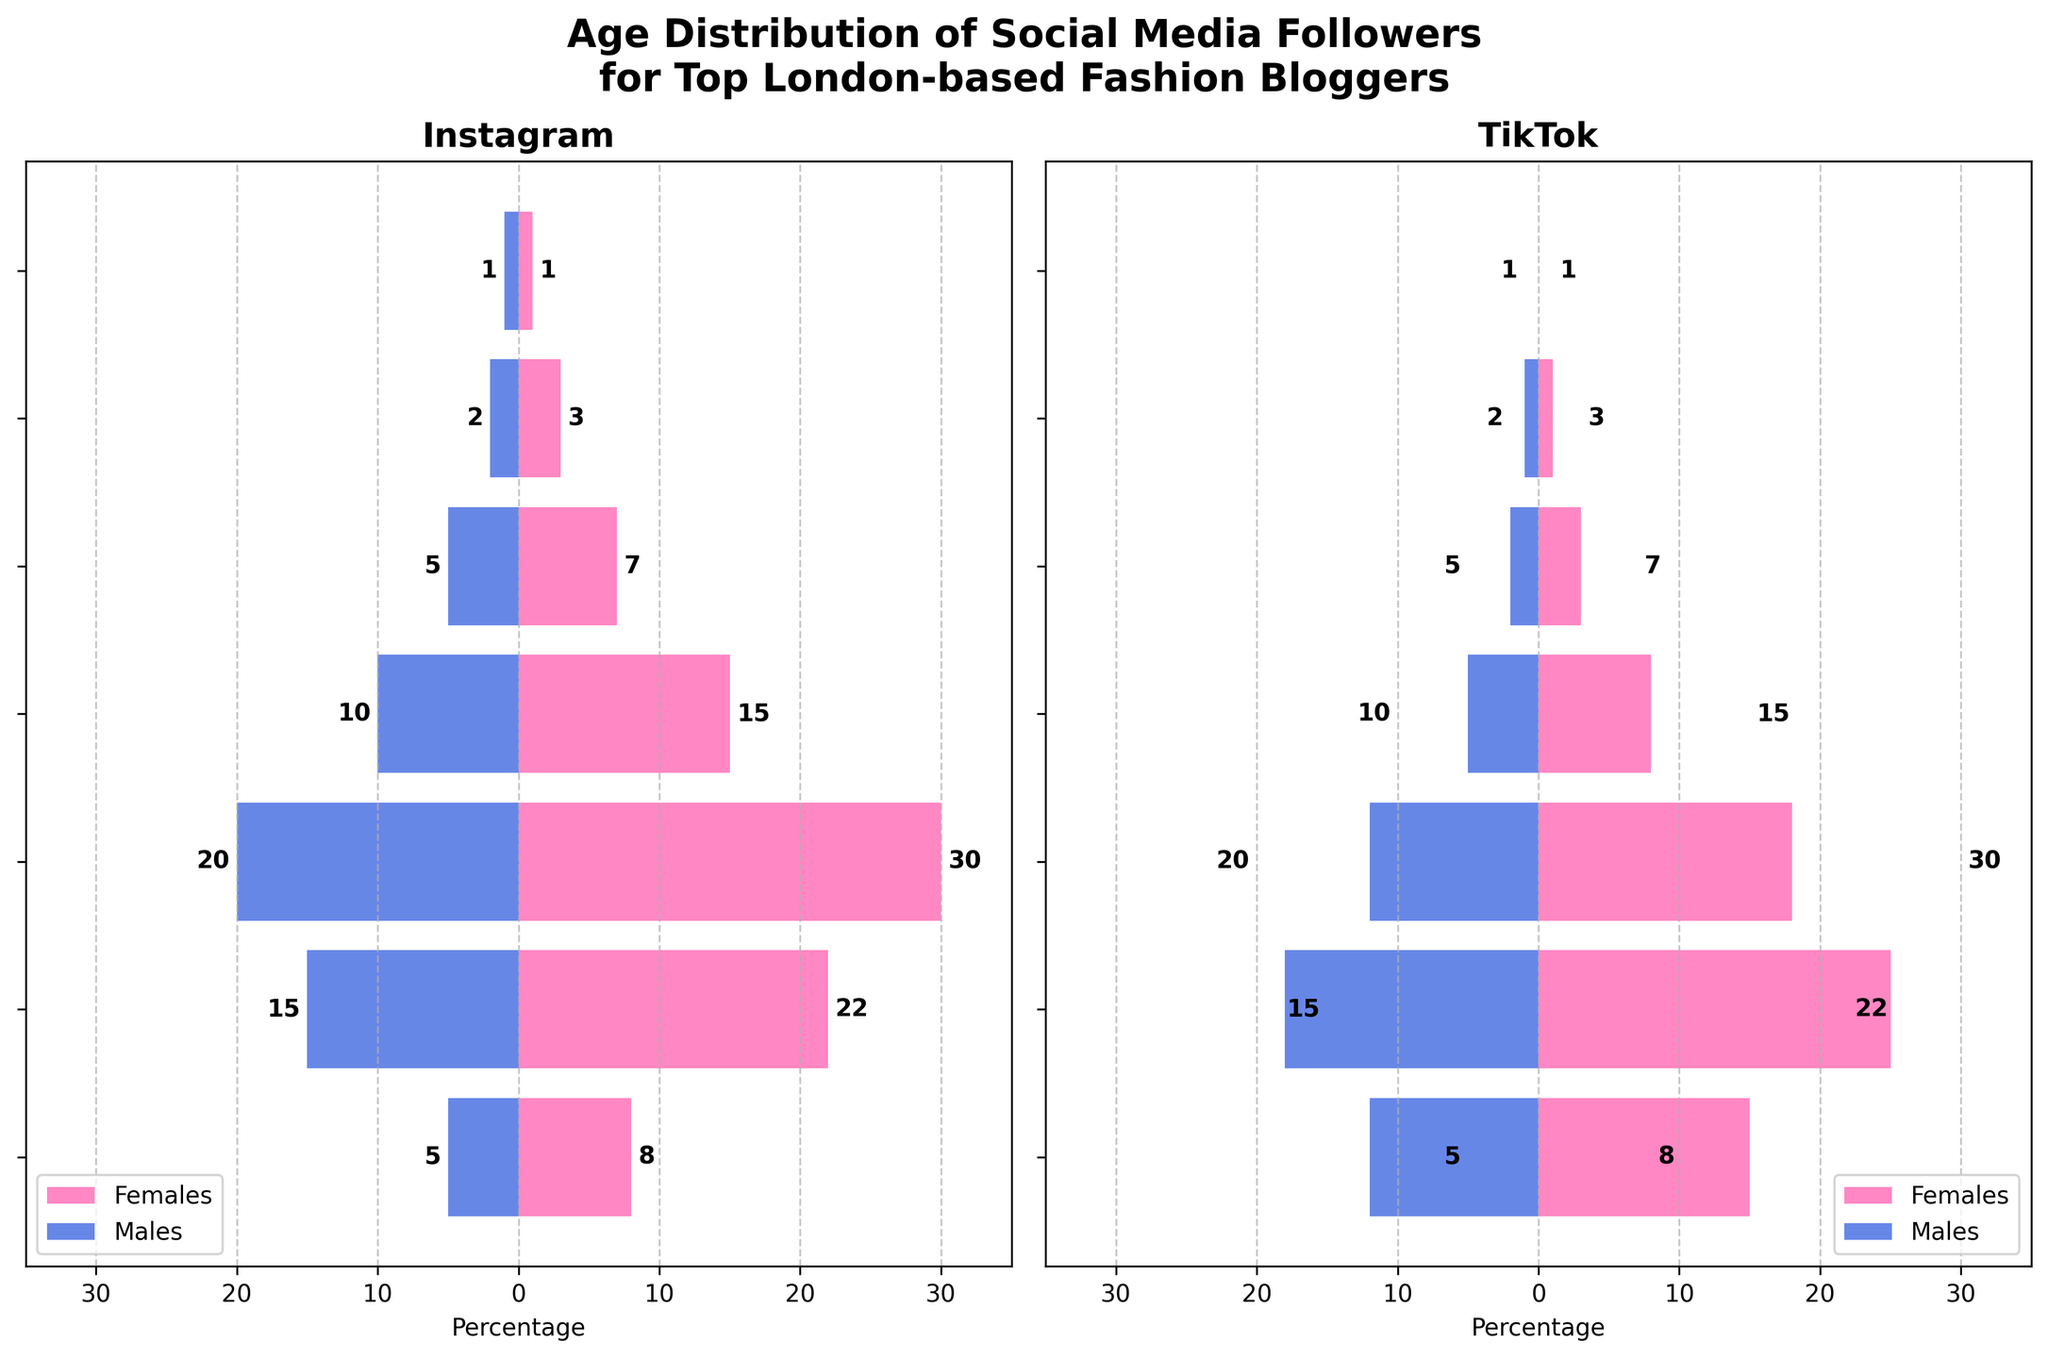What is the title of the figure? The title can be found at the top center of the figure and provides a summary of what the figure is about.
Answer: Age Distribution of Social Media Followers for Top London-based Fashion Bloggers What are the age groups compared in the figure? The age groups are indicated on the vertical axis of the figure (y-axis). They range from 13-17 to 65+.
Answer: 13-17, 18-24, 25-34, 35-44, 45-54, 55-64, 65+ Which social media platform has more male followers in the age group 18-24? To answer this, refer to the horizontal bars for males in the 18-24 age group in both panels representing Instagram and TikTok. Compare the absolute values of both bars: Instagram males have -15, while TikTok males have -18.
Answer: TikTok How do the number of female TikTok followers in the 25-34 age group compare to Instagram followers of the same age group? Check the length of the pink bars for females in the 25-34 age group in both plots. For Instagram, it is 30, and for TikTok, it is 18. Thus, Instagram's number is higher.
Answer: Instagram has more Which age group has the least number of male followers on Instagram? Identify the shortest blue bar representing males on the Instagram panel. The shortest bar corresponds to the 65+ age group with a value of 1.
Answer: 65+ What is the combined number of female followers on TikTok in the 13-17 and 18-24 age groups? Sum up the values of female followers in these age groups on TikTok. For 13-17: 15, and for 18-24: 25. Therefore, the total is 15 + 25.
Answer: 40 Compare the number of followers in the 35-44 age group between TikTok and Instagram for males and identify which platform has fewer followers. Assess the lengths of the blue bars for males in the 35-44 age group in both figures. Instagram has -10 followers, while TikTok has -5 followers. As absolute values, TikTok has fewer.
Answer: TikTok Which platform has more followers in the age group 45-54? Calculate the total number of followers (both males and females) in the 45-54 age group by adding up the values for each gender on both platforms. For Instagram: 7 (females) + 5 (males) = 12. For TikTok: 3 (females) + 2 (males) = 5. Therefore, Instagram has more.
Answer: Instagram What is the difference in the number of female followers between TikTok and Instagram platforms in the 25-34 age group? Subtract the number of female followers on TikTok in the 25-34 age group from the number of female followers on Instagram. Instagram has 30 female followers, while TikTok has 18. The difference is 30 - 18.
Answer: 12 